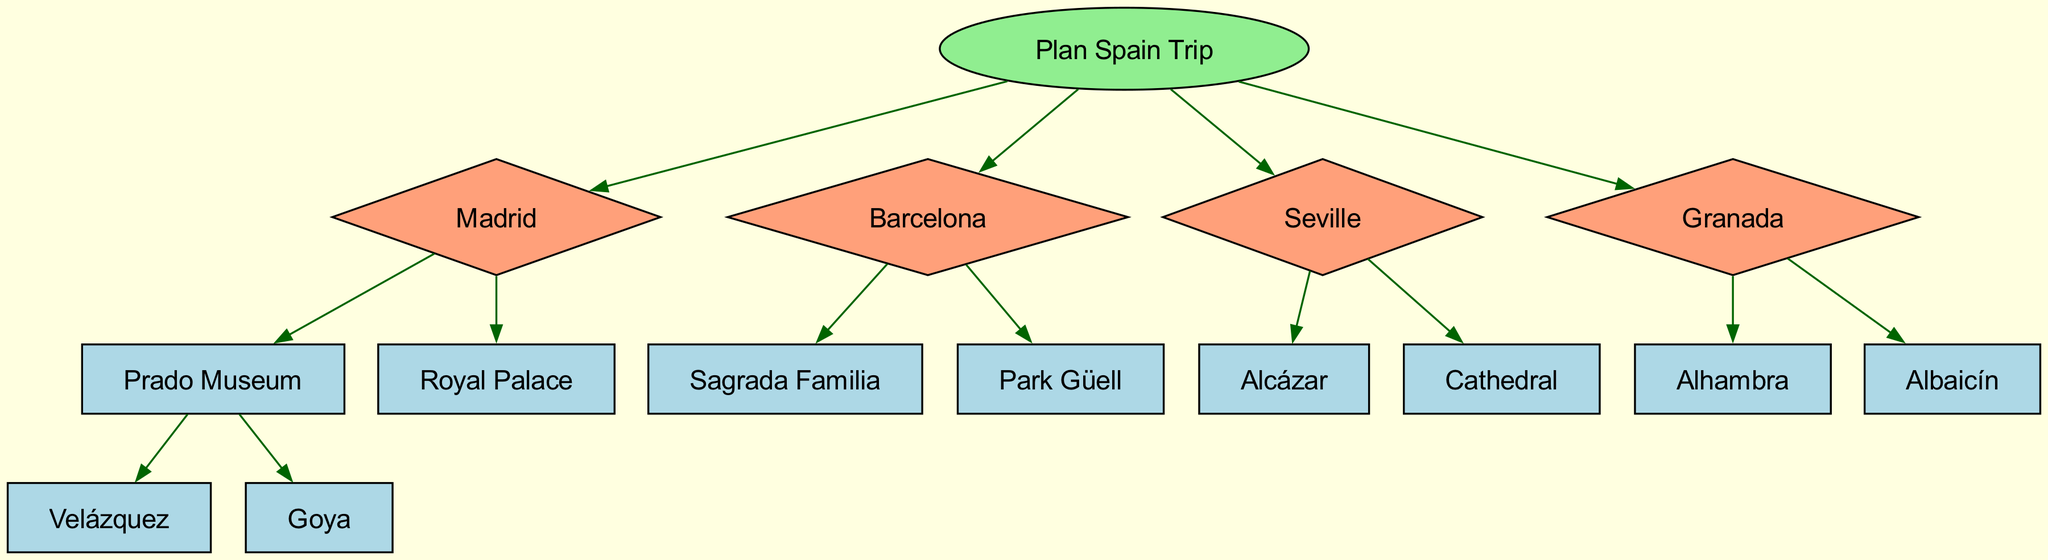What is the root node of the decision tree? The root node is labeled "Plan Spain Trip," indicating the main purpose of the diagram. It's the starting point from which all decisions branch out.
Answer: Plan Spain Trip How many cities are included in the decision tree? There are four cities listed as nodes under the root: Madrid, Barcelona, Seville, and Granada.
Answer: 4 What cultural landmark is associated with Madrid? Madrid has several landmarks, one being the Prado Museum, which is significant for its art collection. It's explicitly identified as a child node of Madrid.
Answer: Prado Museum Which city features the Sagrada Familia? The diagram indicates that Barcelona has the Sagrada Familia as one of its primary cultural landmarks. It's directly listed as a child node under Barcelona.
Answer: Barcelona Name one historical site to visit in Seville. The diagram shows that Seville includes the Alcázar as one notable historical site, specifically mentioned under its child nodes.
Answer: Alcázar What are the two key attractions in Granada? Granada is associated with the Alhambra and the Albaicín, which are both listed as important cultural landmarks under the children's nodes of this city.
Answer: Alhambra and Albaicín Which city provides insight into Renaissance art? Listening to the branches, Madrid is linked with artists like Velázquez and Goya, who are renowned for their Renaissance contributions, making it the city for Renaissance art insights.
Answer: Madrid How many cultural landmarks are shown under Barcelona? Barcelona features two landmarks listed as child nodes: Sagrada Familia and Park Güell. Therefore, the total count is two.
Answer: 2 What type of art is associated with the Prado Museum? The Prado Museum is known for housing works by Velázquez and Goya, indicating it is associated with Spanish Baroque and Romanticism art, respectively.
Answer: Velázquez and Goya 